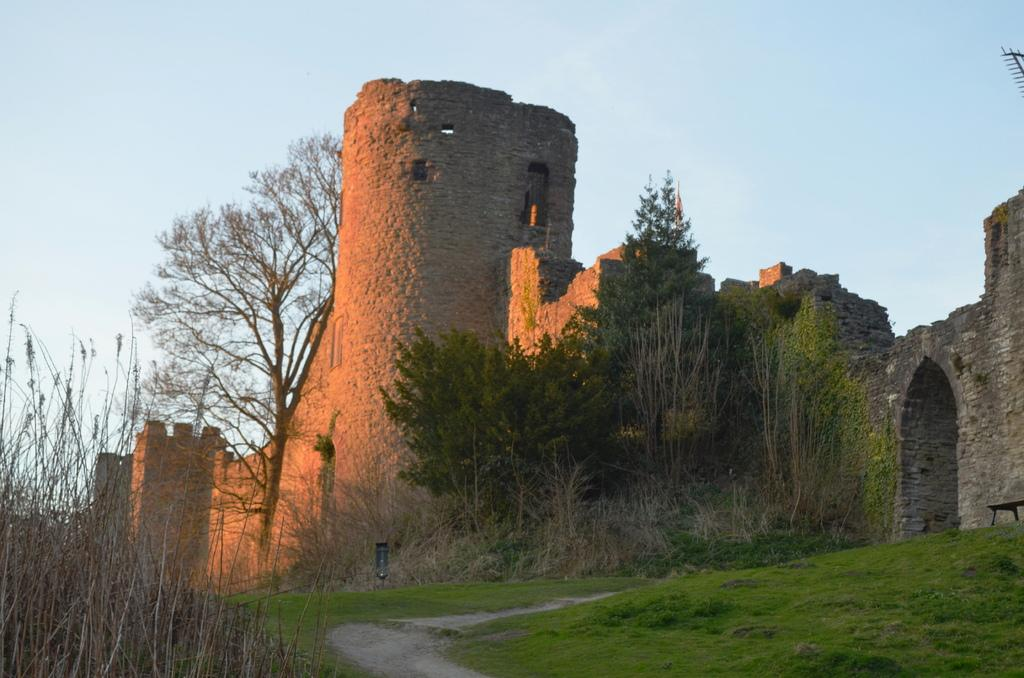What type of surface is visible in the image? There is grass on the surface in the image. What can be seen in the distance behind the grass? There are buildings and trees in the background of the image. What else is visible in the background of the image? The sky is visible in the background of the image. How many children are participating in the committee meeting in the image? There are no children or committee meetings present in the image. 